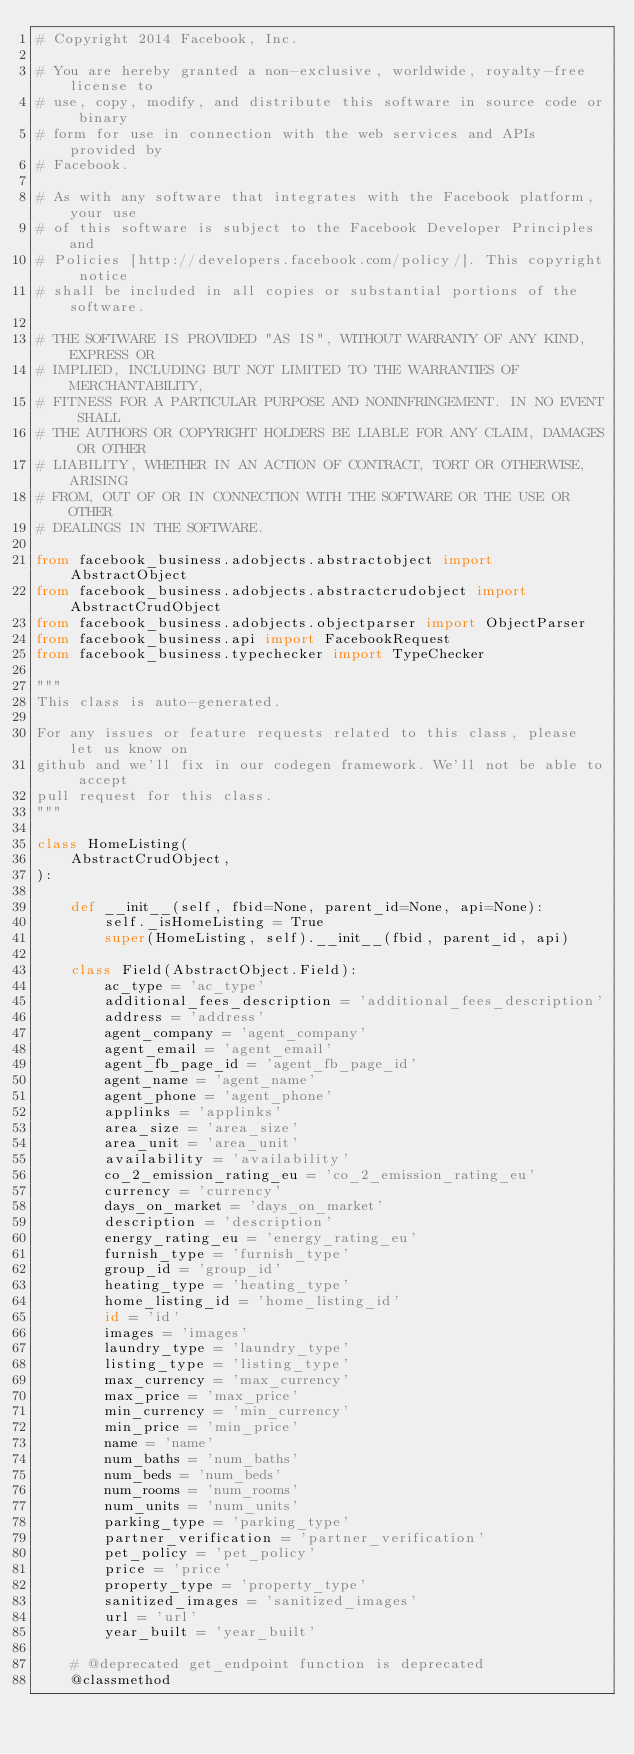<code> <loc_0><loc_0><loc_500><loc_500><_Python_># Copyright 2014 Facebook, Inc.

# You are hereby granted a non-exclusive, worldwide, royalty-free license to
# use, copy, modify, and distribute this software in source code or binary
# form for use in connection with the web services and APIs provided by
# Facebook.

# As with any software that integrates with the Facebook platform, your use
# of this software is subject to the Facebook Developer Principles and
# Policies [http://developers.facebook.com/policy/]. This copyright notice
# shall be included in all copies or substantial portions of the software.

# THE SOFTWARE IS PROVIDED "AS IS", WITHOUT WARRANTY OF ANY KIND, EXPRESS OR
# IMPLIED, INCLUDING BUT NOT LIMITED TO THE WARRANTIES OF MERCHANTABILITY,
# FITNESS FOR A PARTICULAR PURPOSE AND NONINFRINGEMENT. IN NO EVENT SHALL
# THE AUTHORS OR COPYRIGHT HOLDERS BE LIABLE FOR ANY CLAIM, DAMAGES OR OTHER
# LIABILITY, WHETHER IN AN ACTION OF CONTRACT, TORT OR OTHERWISE, ARISING
# FROM, OUT OF OR IN CONNECTION WITH THE SOFTWARE OR THE USE OR OTHER
# DEALINGS IN THE SOFTWARE.

from facebook_business.adobjects.abstractobject import AbstractObject
from facebook_business.adobjects.abstractcrudobject import AbstractCrudObject
from facebook_business.adobjects.objectparser import ObjectParser
from facebook_business.api import FacebookRequest
from facebook_business.typechecker import TypeChecker

"""
This class is auto-generated.

For any issues or feature requests related to this class, please let us know on
github and we'll fix in our codegen framework. We'll not be able to accept
pull request for this class.
"""

class HomeListing(
    AbstractCrudObject,
):

    def __init__(self, fbid=None, parent_id=None, api=None):
        self._isHomeListing = True
        super(HomeListing, self).__init__(fbid, parent_id, api)

    class Field(AbstractObject.Field):
        ac_type = 'ac_type'
        additional_fees_description = 'additional_fees_description'
        address = 'address'
        agent_company = 'agent_company'
        agent_email = 'agent_email'
        agent_fb_page_id = 'agent_fb_page_id'
        agent_name = 'agent_name'
        agent_phone = 'agent_phone'
        applinks = 'applinks'
        area_size = 'area_size'
        area_unit = 'area_unit'
        availability = 'availability'
        co_2_emission_rating_eu = 'co_2_emission_rating_eu'
        currency = 'currency'
        days_on_market = 'days_on_market'
        description = 'description'
        energy_rating_eu = 'energy_rating_eu'
        furnish_type = 'furnish_type'
        group_id = 'group_id'
        heating_type = 'heating_type'
        home_listing_id = 'home_listing_id'
        id = 'id'
        images = 'images'
        laundry_type = 'laundry_type'
        listing_type = 'listing_type'
        max_currency = 'max_currency'
        max_price = 'max_price'
        min_currency = 'min_currency'
        min_price = 'min_price'
        name = 'name'
        num_baths = 'num_baths'
        num_beds = 'num_beds'
        num_rooms = 'num_rooms'
        num_units = 'num_units'
        parking_type = 'parking_type'
        partner_verification = 'partner_verification'
        pet_policy = 'pet_policy'
        price = 'price'
        property_type = 'property_type'
        sanitized_images = 'sanitized_images'
        url = 'url'
        year_built = 'year_built'

    # @deprecated get_endpoint function is deprecated
    @classmethod</code> 